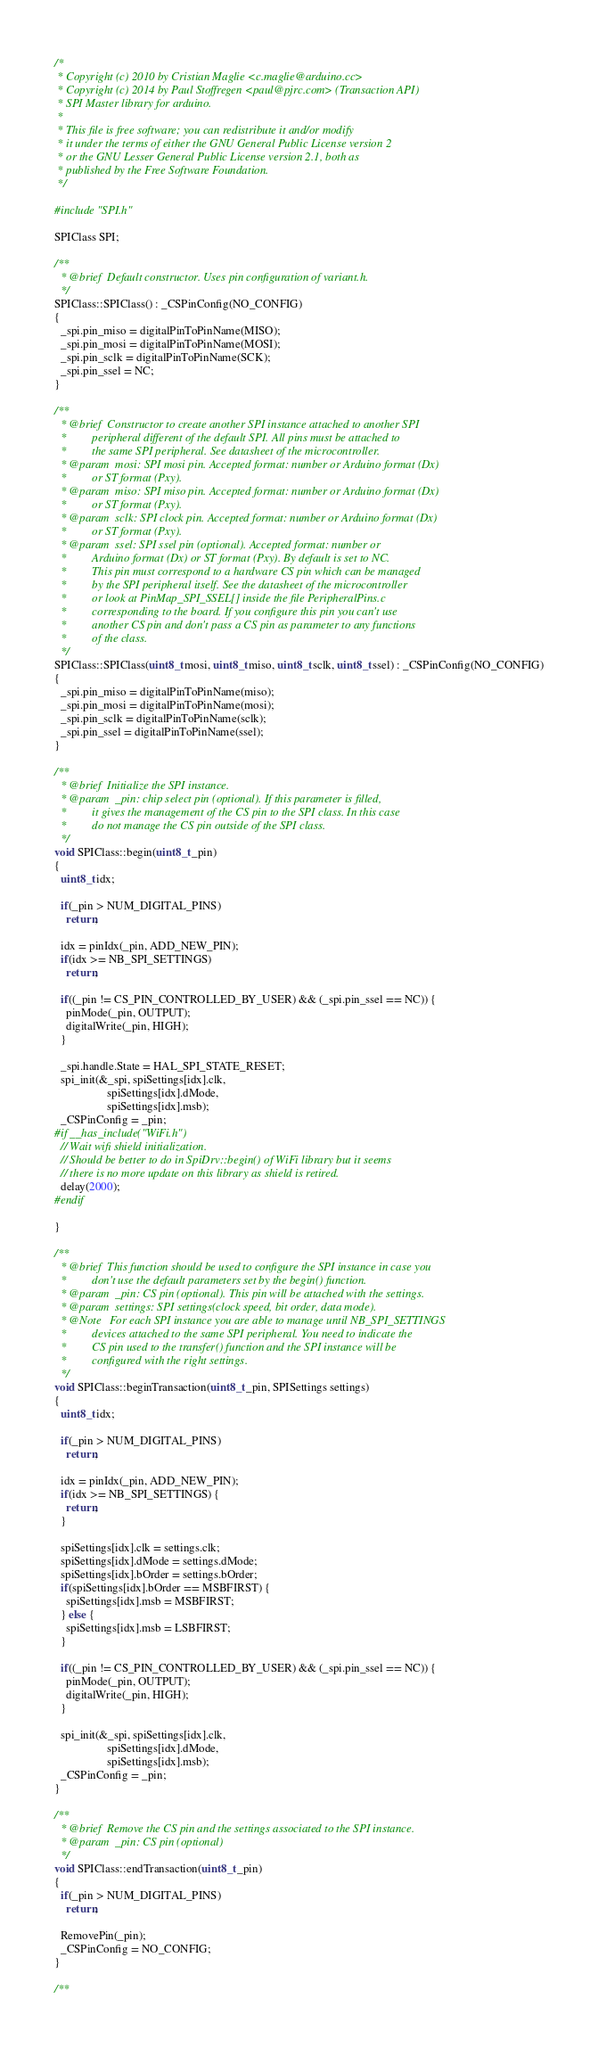<code> <loc_0><loc_0><loc_500><loc_500><_C++_>/*
 * Copyright (c) 2010 by Cristian Maglie <c.maglie@arduino.cc>
 * Copyright (c) 2014 by Paul Stoffregen <paul@pjrc.com> (Transaction API)
 * SPI Master library for arduino.
 *
 * This file is free software; you can redistribute it and/or modify
 * it under the terms of either the GNU General Public License version 2
 * or the GNU Lesser General Public License version 2.1, both as
 * published by the Free Software Foundation.
 */

#include "SPI.h"

SPIClass SPI;

/**
  * @brief  Default constructor. Uses pin configuration of variant.h.
  */
SPIClass::SPIClass() : _CSPinConfig(NO_CONFIG)
{
  _spi.pin_miso = digitalPinToPinName(MISO);
  _spi.pin_mosi = digitalPinToPinName(MOSI);
  _spi.pin_sclk = digitalPinToPinName(SCK);
  _spi.pin_ssel = NC;
}

/**
  * @brief  Constructor to create another SPI instance attached to another SPI
  *         peripheral different of the default SPI. All pins must be attached to
  *         the same SPI peripheral. See datasheet of the microcontroller.
  * @param  mosi: SPI mosi pin. Accepted format: number or Arduino format (Dx)
  *         or ST format (Pxy).
  * @param  miso: SPI miso pin. Accepted format: number or Arduino format (Dx)
  *         or ST format (Pxy).
  * @param  sclk: SPI clock pin. Accepted format: number or Arduino format (Dx)
  *         or ST format (Pxy).
  * @param  ssel: SPI ssel pin (optional). Accepted format: number or
  *         Arduino format (Dx) or ST format (Pxy). By default is set to NC.
  *         This pin must correspond to a hardware CS pin which can be managed
  *         by the SPI peripheral itself. See the datasheet of the microcontroller
  *         or look at PinMap_SPI_SSEL[] inside the file PeripheralPins.c
  *         corresponding to the board. If you configure this pin you can't use
  *         another CS pin and don't pass a CS pin as parameter to any functions
  *         of the class.
  */
SPIClass::SPIClass(uint8_t mosi, uint8_t miso, uint8_t sclk, uint8_t ssel) : _CSPinConfig(NO_CONFIG)
{
  _spi.pin_miso = digitalPinToPinName(miso);
  _spi.pin_mosi = digitalPinToPinName(mosi);
  _spi.pin_sclk = digitalPinToPinName(sclk);
  _spi.pin_ssel = digitalPinToPinName(ssel);
}

/**
  * @brief  Initialize the SPI instance.
  * @param  _pin: chip select pin (optional). If this parameter is filled,
  *         it gives the management of the CS pin to the SPI class. In this case
  *         do not manage the CS pin outside of the SPI class.
  */
void SPIClass::begin(uint8_t _pin)
{
  uint8_t idx;

  if(_pin > NUM_DIGITAL_PINS)
    return;

  idx = pinIdx(_pin, ADD_NEW_PIN);
  if(idx >= NB_SPI_SETTINGS)
    return;

  if((_pin != CS_PIN_CONTROLLED_BY_USER) && (_spi.pin_ssel == NC)) {
    pinMode(_pin, OUTPUT);
    digitalWrite(_pin, HIGH);
  }

  _spi.handle.State = HAL_SPI_STATE_RESET;
  spi_init(&_spi, spiSettings[idx].clk,
                  spiSettings[idx].dMode,
                  spiSettings[idx].msb);
  _CSPinConfig = _pin;
#if __has_include("WiFi.h")
  // Wait wifi shield initialization.
  // Should be better to do in SpiDrv::begin() of WiFi library but it seems
  // there is no more update on this library as shield is retired.
  delay(2000);
#endif

}

/**
  * @brief  This function should be used to configure the SPI instance in case you
  *         don't use the default parameters set by the begin() function.
  * @param  _pin: CS pin (optional). This pin will be attached with the settings.
  * @param  settings: SPI settings(clock speed, bit order, data mode).
  * @Note   For each SPI instance you are able to manage until NB_SPI_SETTINGS
  *         devices attached to the same SPI peripheral. You need to indicate the
  *         CS pin used to the transfer() function and the SPI instance will be
  *         configured with the right settings.
  */
void SPIClass::beginTransaction(uint8_t _pin, SPISettings settings)
{
  uint8_t idx;

  if(_pin > NUM_DIGITAL_PINS)
    return;

  idx = pinIdx(_pin, ADD_NEW_PIN);
  if(idx >= NB_SPI_SETTINGS) {
    return;
  }

  spiSettings[idx].clk = settings.clk;
  spiSettings[idx].dMode = settings.dMode;
  spiSettings[idx].bOrder = settings.bOrder;
  if(spiSettings[idx].bOrder == MSBFIRST) {
    spiSettings[idx].msb = MSBFIRST;
  } else {
    spiSettings[idx].msb = LSBFIRST;
  }

  if((_pin != CS_PIN_CONTROLLED_BY_USER) && (_spi.pin_ssel == NC)) {
    pinMode(_pin, OUTPUT);
    digitalWrite(_pin, HIGH);
  }

  spi_init(&_spi, spiSettings[idx].clk,
                  spiSettings[idx].dMode,
                  spiSettings[idx].msb);
  _CSPinConfig = _pin;
}

/**
  * @brief  Remove the CS pin and the settings associated to the SPI instance.
  * @param  _pin: CS pin (optional)
  */
void SPIClass::endTransaction(uint8_t _pin)
{
  if(_pin > NUM_DIGITAL_PINS)
    return;

  RemovePin(_pin);
  _CSPinConfig = NO_CONFIG;
}

/**</code> 